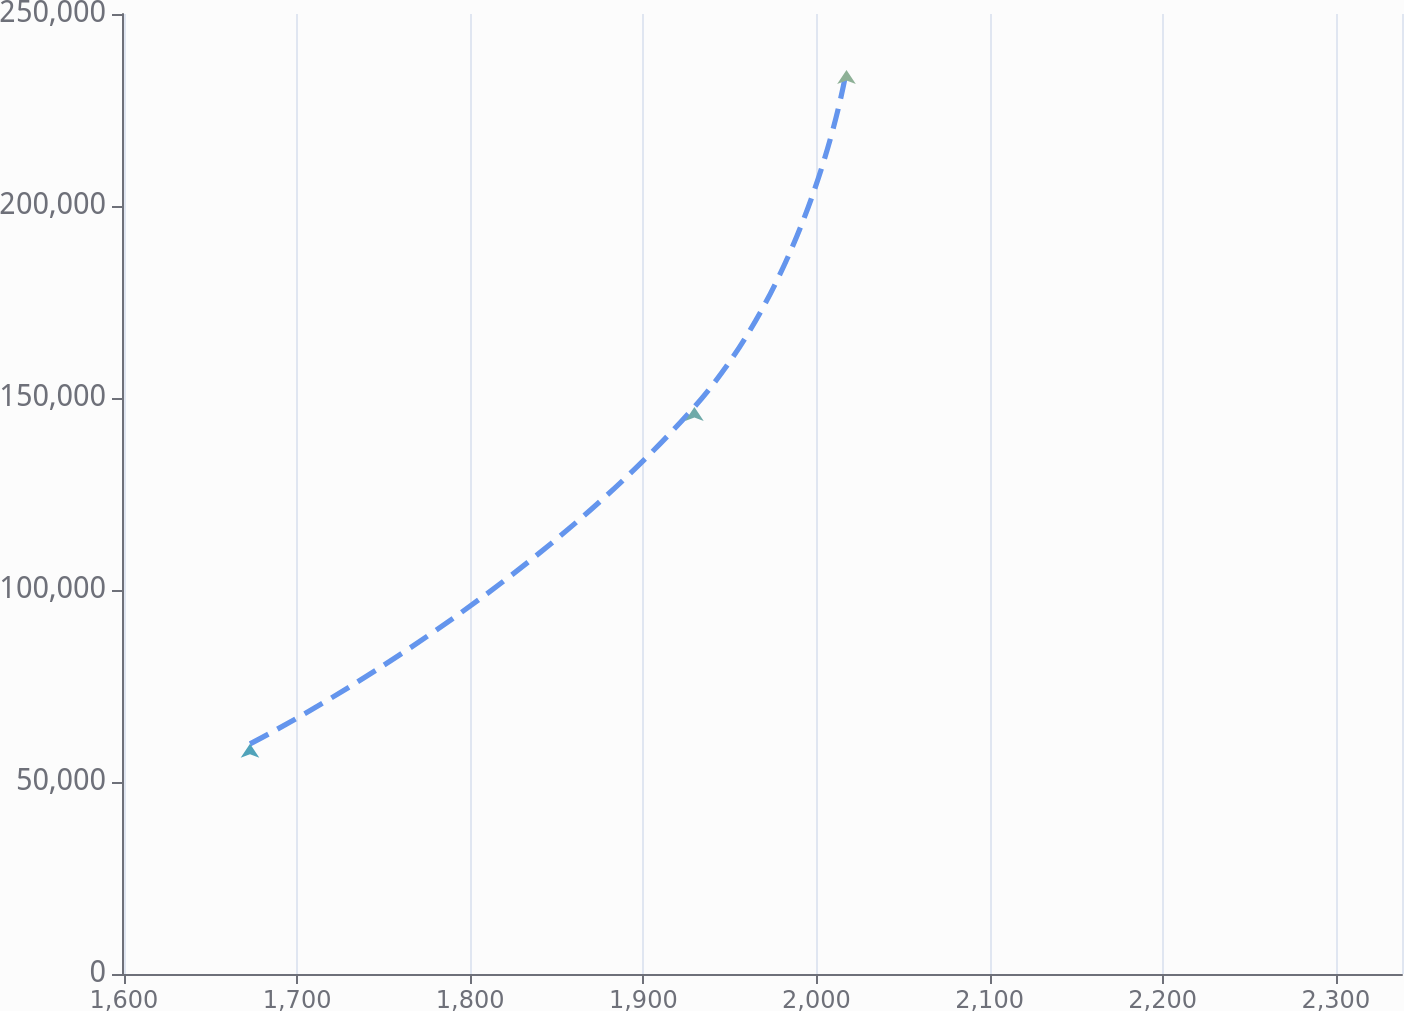Convert chart. <chart><loc_0><loc_0><loc_500><loc_500><line_chart><ecel><fcel>$ 457,805<nl><fcel>1672.81<fcel>59939.6<nl><fcel>1929.5<fcel>147684<nl><fcel>2017.36<fcel>235428<nl><fcel>2412.17<fcel>937383<nl></chart> 